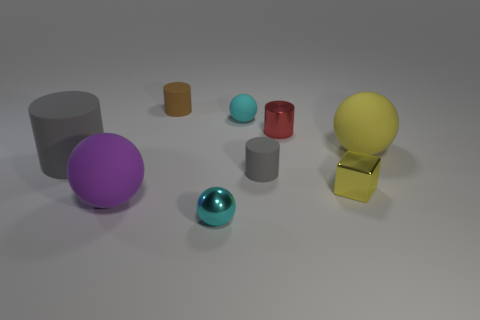Subtract all cyan cylinders. Subtract all red blocks. How many cylinders are left? 4 Add 1 large yellow rubber objects. How many objects exist? 10 Subtract all cylinders. How many objects are left? 5 Add 8 tiny brown objects. How many tiny brown objects are left? 9 Add 2 tiny yellow spheres. How many tiny yellow spheres exist? 2 Subtract 0 red balls. How many objects are left? 9 Subtract all tiny cyan spheres. Subtract all brown rubber cylinders. How many objects are left? 6 